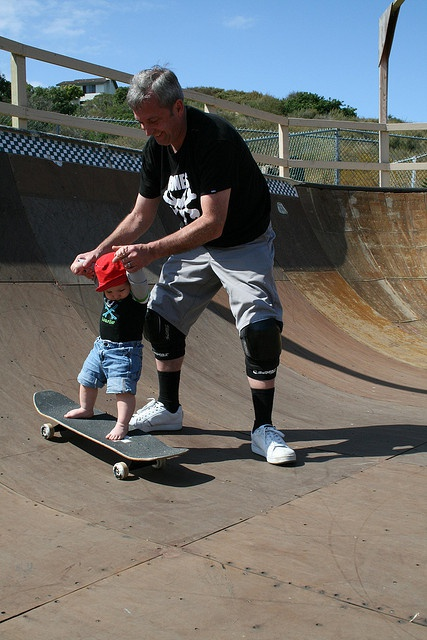Describe the objects in this image and their specific colors. I can see people in lightblue, black, gray, maroon, and lightgray tones, people in lightblue, black, maroon, gray, and navy tones, and skateboard in lightblue, gray, black, and ivory tones in this image. 